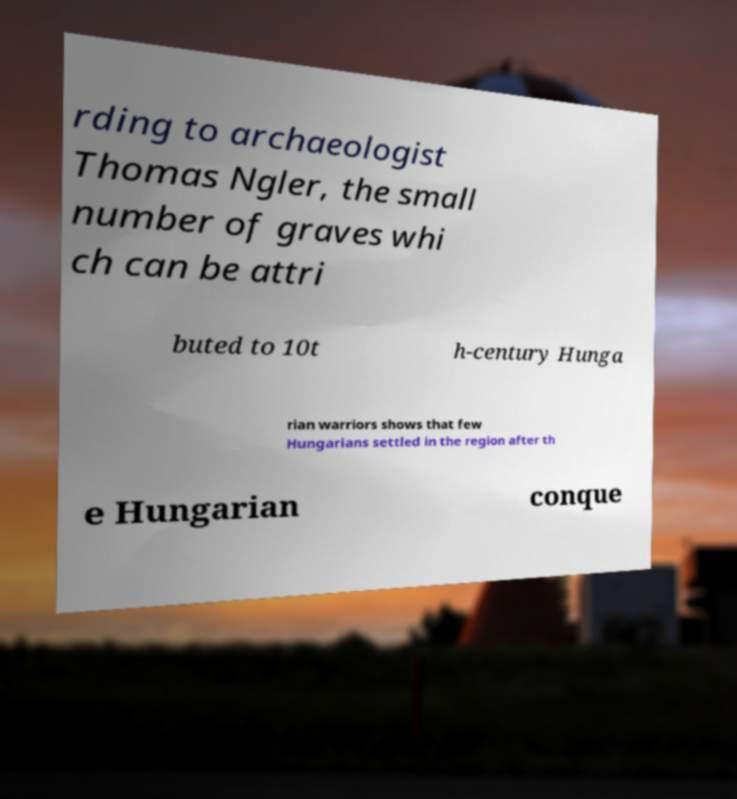For documentation purposes, I need the text within this image transcribed. Could you provide that? rding to archaeologist Thomas Ngler, the small number of graves whi ch can be attri buted to 10t h-century Hunga rian warriors shows that few Hungarians settled in the region after th e Hungarian conque 